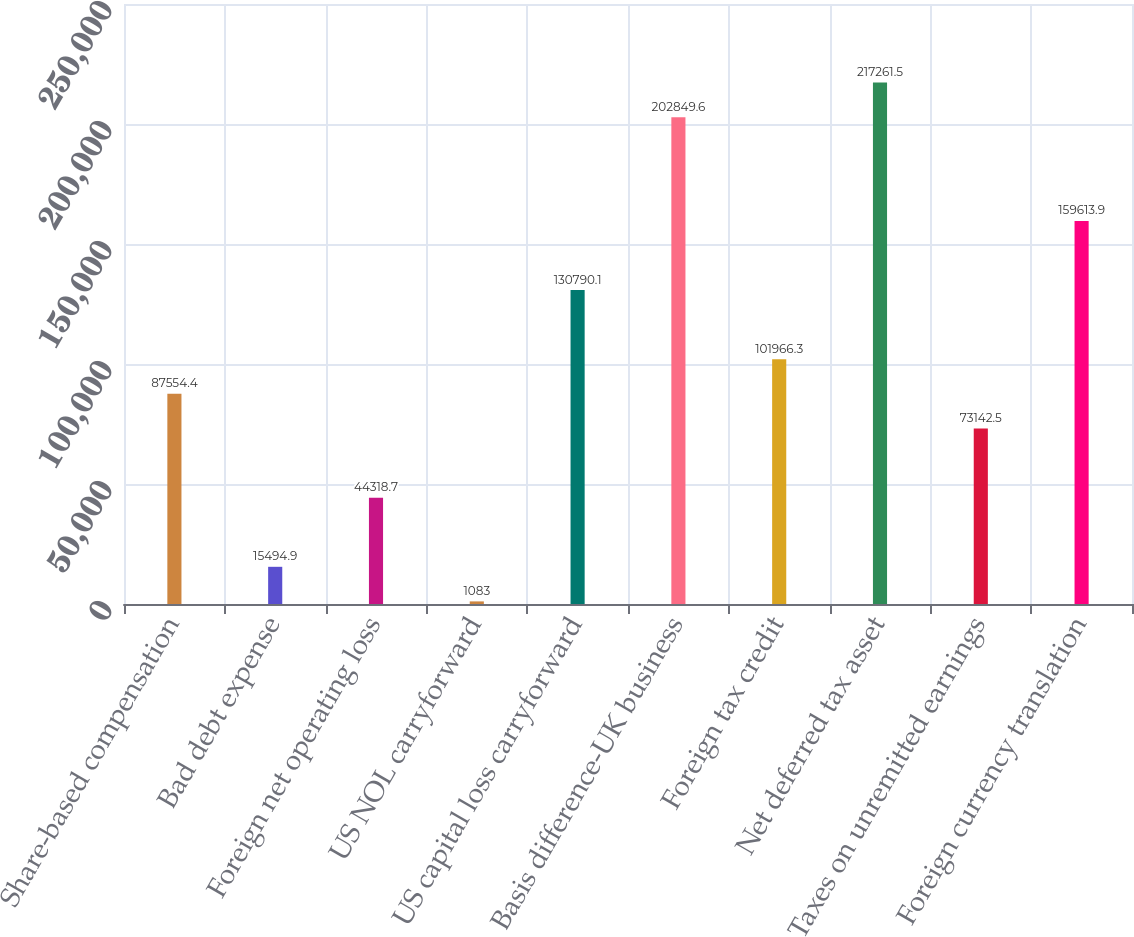<chart> <loc_0><loc_0><loc_500><loc_500><bar_chart><fcel>Share-based compensation<fcel>Bad debt expense<fcel>Foreign net operating loss<fcel>US NOL carryforward<fcel>US capital loss carryforward<fcel>Basis difference-UK business<fcel>Foreign tax credit<fcel>Net deferred tax asset<fcel>Taxes on unremitted earnings<fcel>Foreign currency translation<nl><fcel>87554.4<fcel>15494.9<fcel>44318.7<fcel>1083<fcel>130790<fcel>202850<fcel>101966<fcel>217262<fcel>73142.5<fcel>159614<nl></chart> 